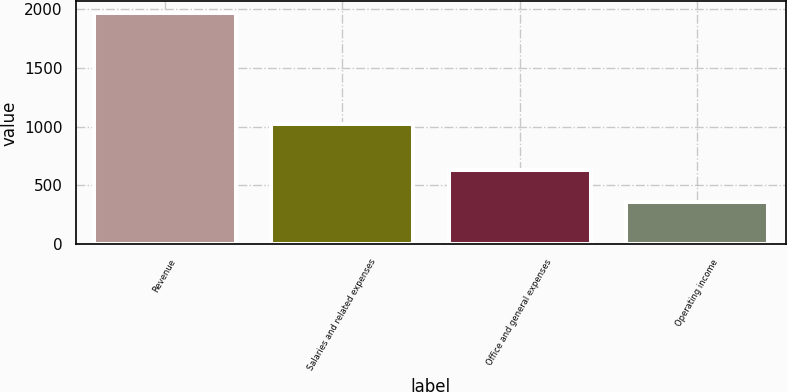Convert chart to OTSL. <chart><loc_0><loc_0><loc_500><loc_500><bar_chart><fcel>Revenue<fcel>Salaries and related expenses<fcel>Office and general expenses<fcel>Operating income<nl><fcel>1965.7<fcel>1021.9<fcel>630.3<fcel>359.2<nl></chart> 